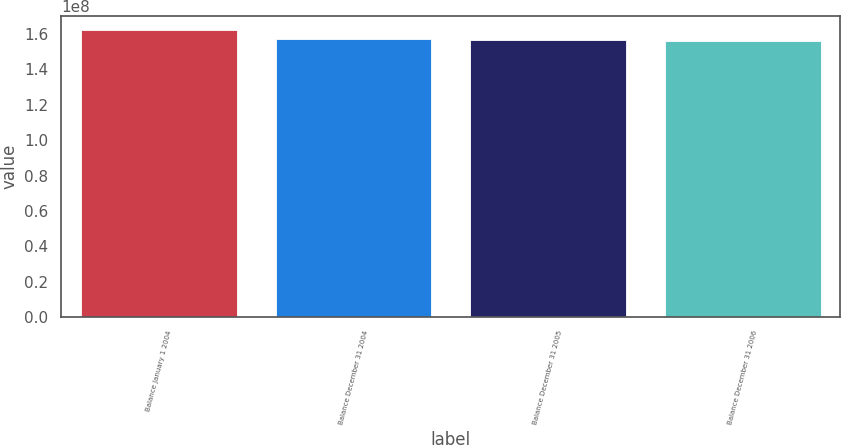Convert chart to OTSL. <chart><loc_0><loc_0><loc_500><loc_500><bar_chart><fcel>Balance January 1 2004<fcel>Balance December 31 2004<fcel>Balance December 31 2005<fcel>Balance December 31 2006<nl><fcel>1.62315e+08<fcel>1.57518e+08<fcel>1.56918e+08<fcel>1.56319e+08<nl></chart> 